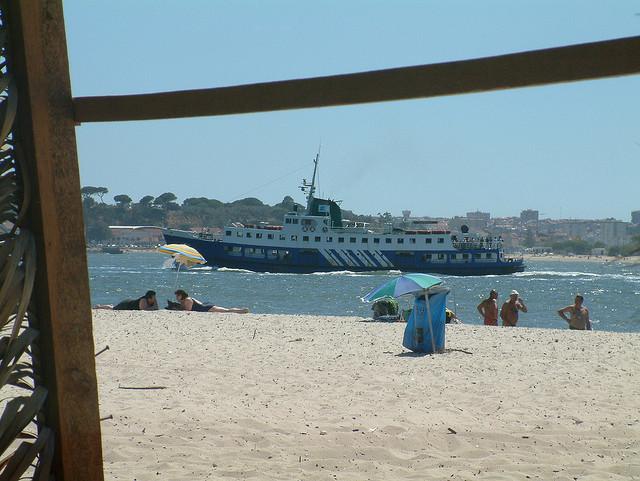How many umbrellas are there?
Keep it brief. 2. What direction are the majority of ships facing?
Be succinct. Left. Is it hot?
Short answer required. Yes. Is this a big boat or a small boat?
Concise answer only. Big. 